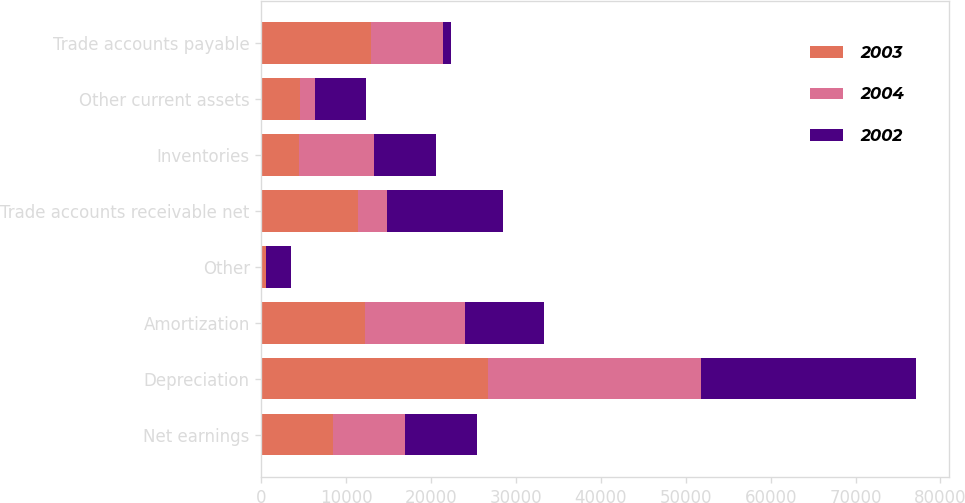Convert chart to OTSL. <chart><loc_0><loc_0><loc_500><loc_500><stacked_bar_chart><ecel><fcel>Net earnings<fcel>Depreciation<fcel>Amortization<fcel>Other<fcel>Trade accounts receivable net<fcel>Inventories<fcel>Other current assets<fcel>Trade accounts payable<nl><fcel>2003<fcel>8452<fcel>26668<fcel>12256<fcel>569<fcel>11337<fcel>4449<fcel>4584<fcel>12934<nl><fcel>2004<fcel>8452<fcel>25086<fcel>11724<fcel>13<fcel>3516<fcel>8773<fcel>1708<fcel>8452<nl><fcel>2002<fcel>8452<fcel>25392<fcel>9332<fcel>2950<fcel>13663<fcel>7378<fcel>6061<fcel>919<nl></chart> 